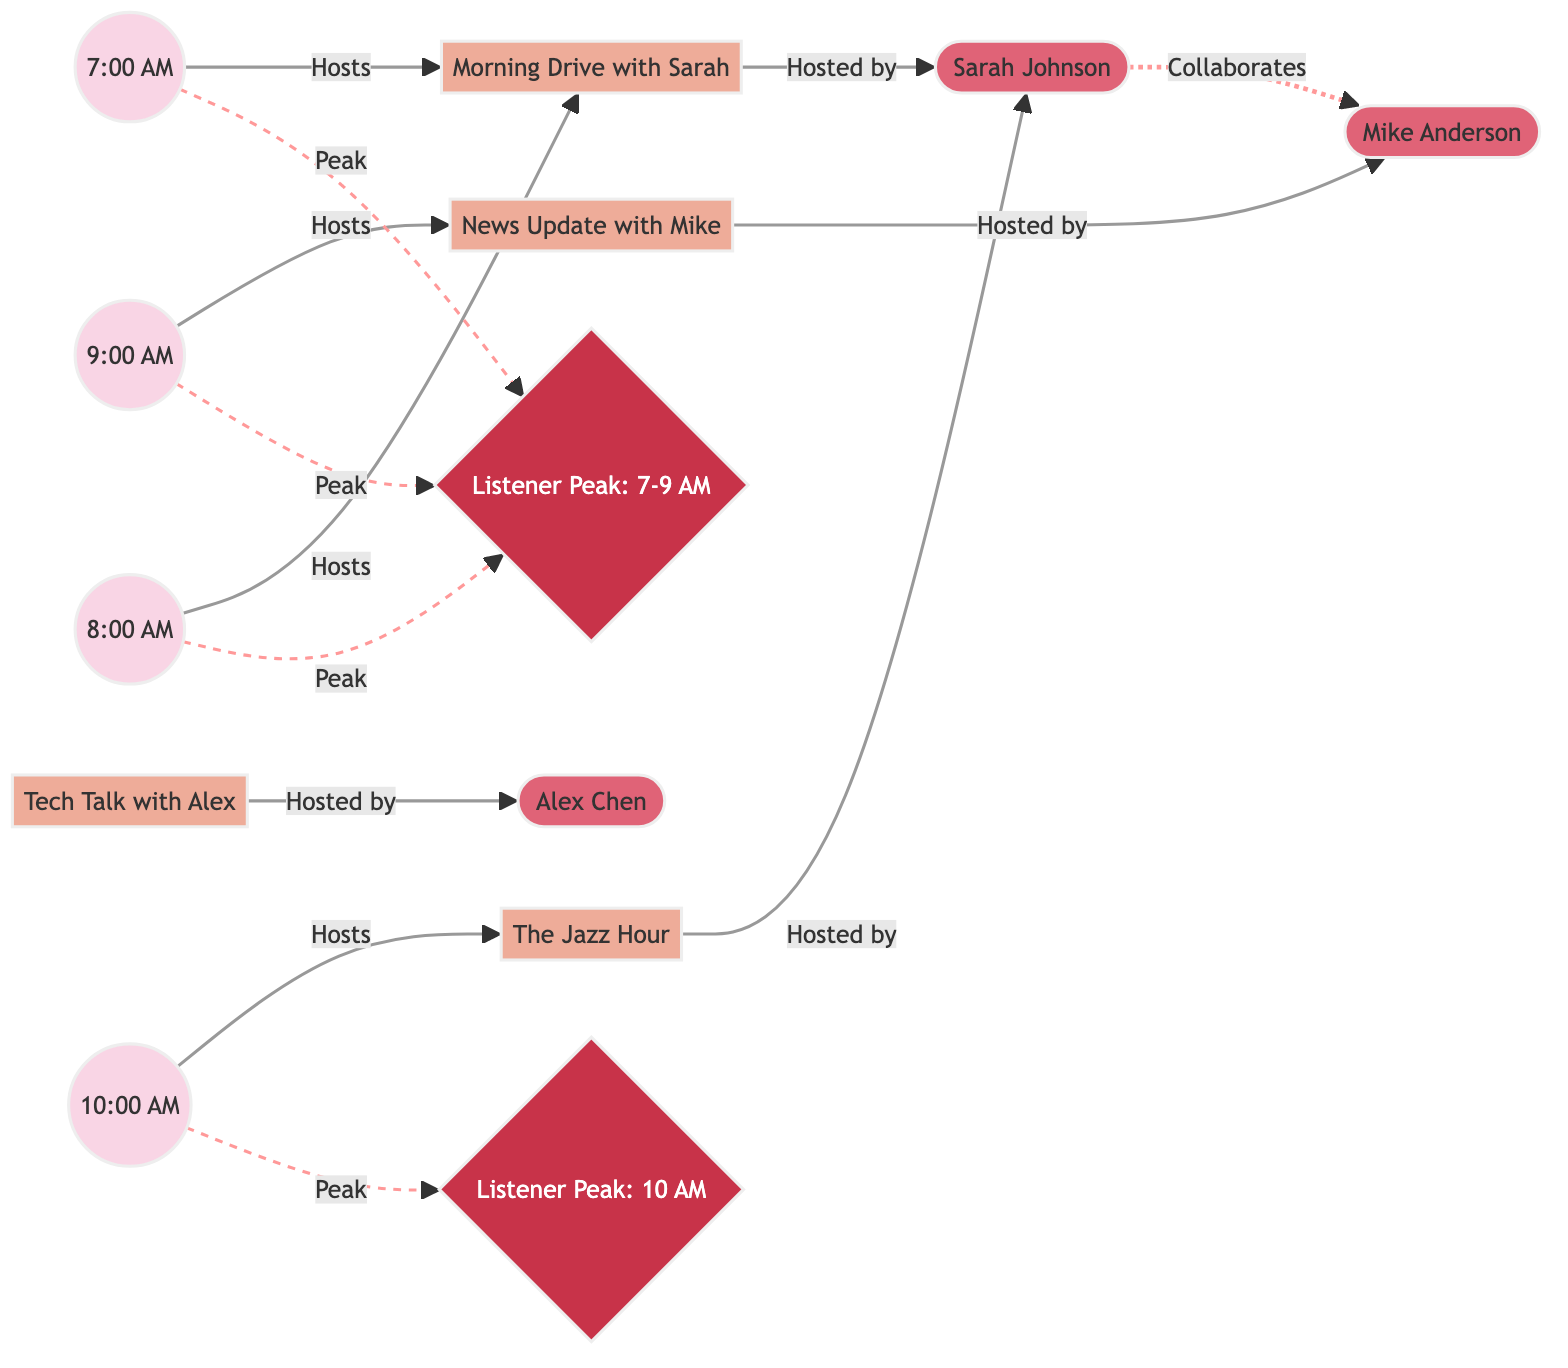What shows air during the 8:00 AM slot? The 8:00 AM slot is connected to the "Morning Drive with Sarah" show, indicating that this is the show that airs during this time.
Answer: Morning Drive with Sarah How many hosts are connected to shows in the diagram? The three hosts (Sarah Johnson, Mike Anderson, and Alex Chen) are each connected to one or more shows. Therefore, the count is three.
Answer: 3 What type of relationship exists between Sarah Johnson and Mike Anderson? The diagram shows a dashed line labeled "collaborates" between Sarah and Mike, indicating that they have a collaborative relationship.
Answer: collaboration Which listener peak time corresponds to the 10:00 AM slot? The diagram indicates that the 10:00 AM slot is connected to "Listener Peak Time: 10 AM," showing that this time is specifically highlighted for increased listener engagement.
Answer: Listener Peak Time: 10 AM How many total nodes are there in this diagram? Counting all nodes in the diagram, including time slots, shows, hosts, and listener peak times, gives a total of 14 nodes.
Answer: 14 What shows are hosted by Sarah Johnson? Sarah Johnson hosts both "Morning Drive with Sarah" and "The Jazz Hour," as indicated by the edges in the diagram.
Answer: Morning Drive with Sarah, The Jazz Hour At what times do listener peak times occur? The listener peak times identified in the diagram are 7-9 AM and 10 AM, showing when listener engagement is highest.
Answer: 7-9 AM, 10 AM Which show is associated with Mike Anderson? The diagram connects Mike Anderson with "News Update with Mike," showing he is the host of this show.
Answer: News Update with Mike 